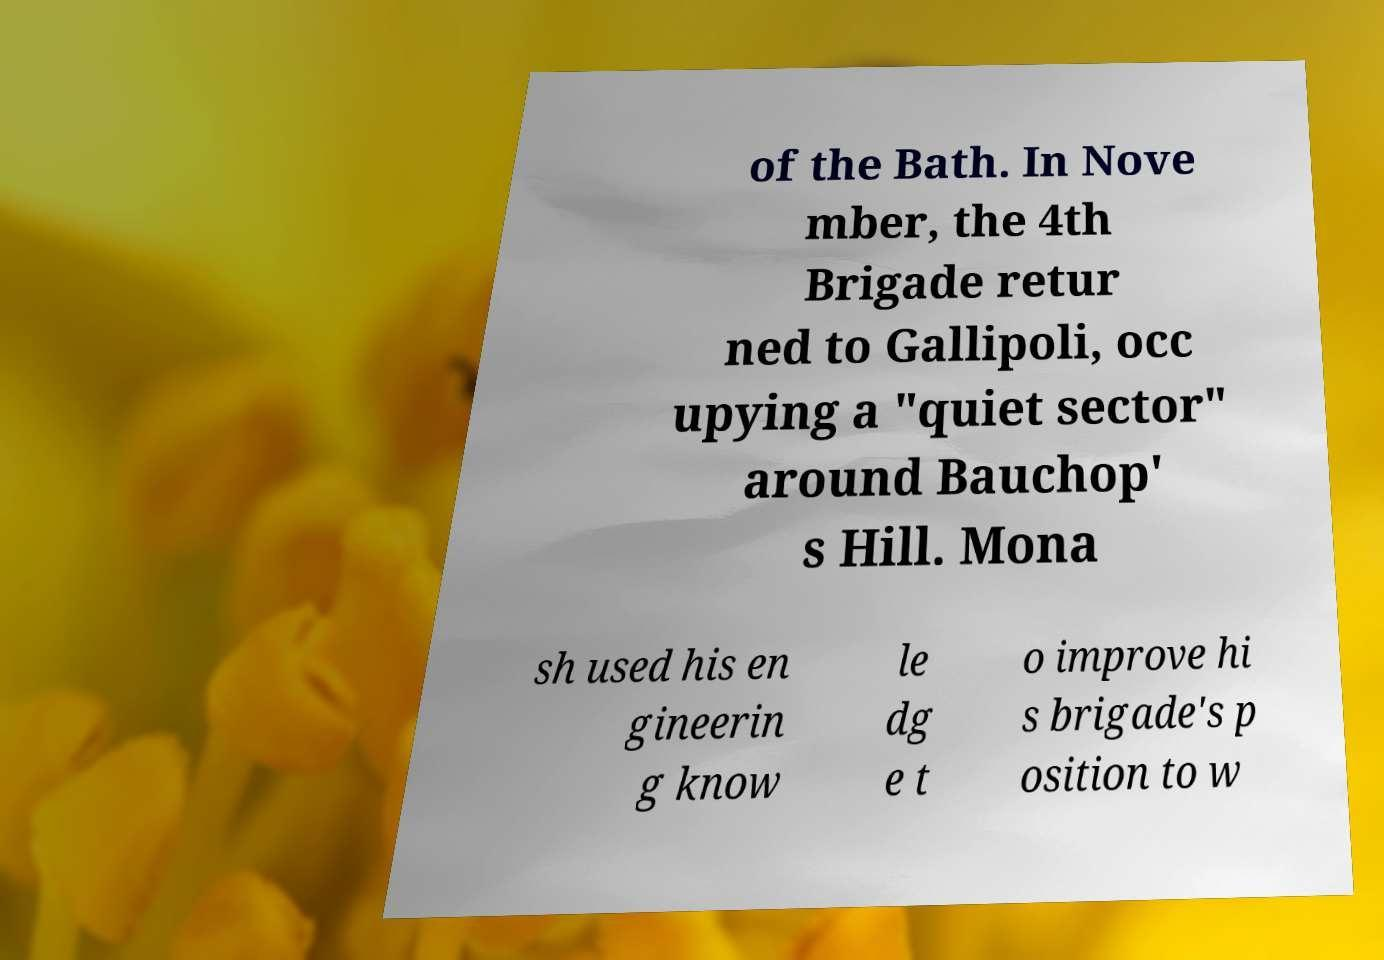Please read and relay the text visible in this image. What does it say? of the Bath. In Nove mber, the 4th Brigade retur ned to Gallipoli, occ upying a "quiet sector" around Bauchop' s Hill. Mona sh used his en gineerin g know le dg e t o improve hi s brigade's p osition to w 